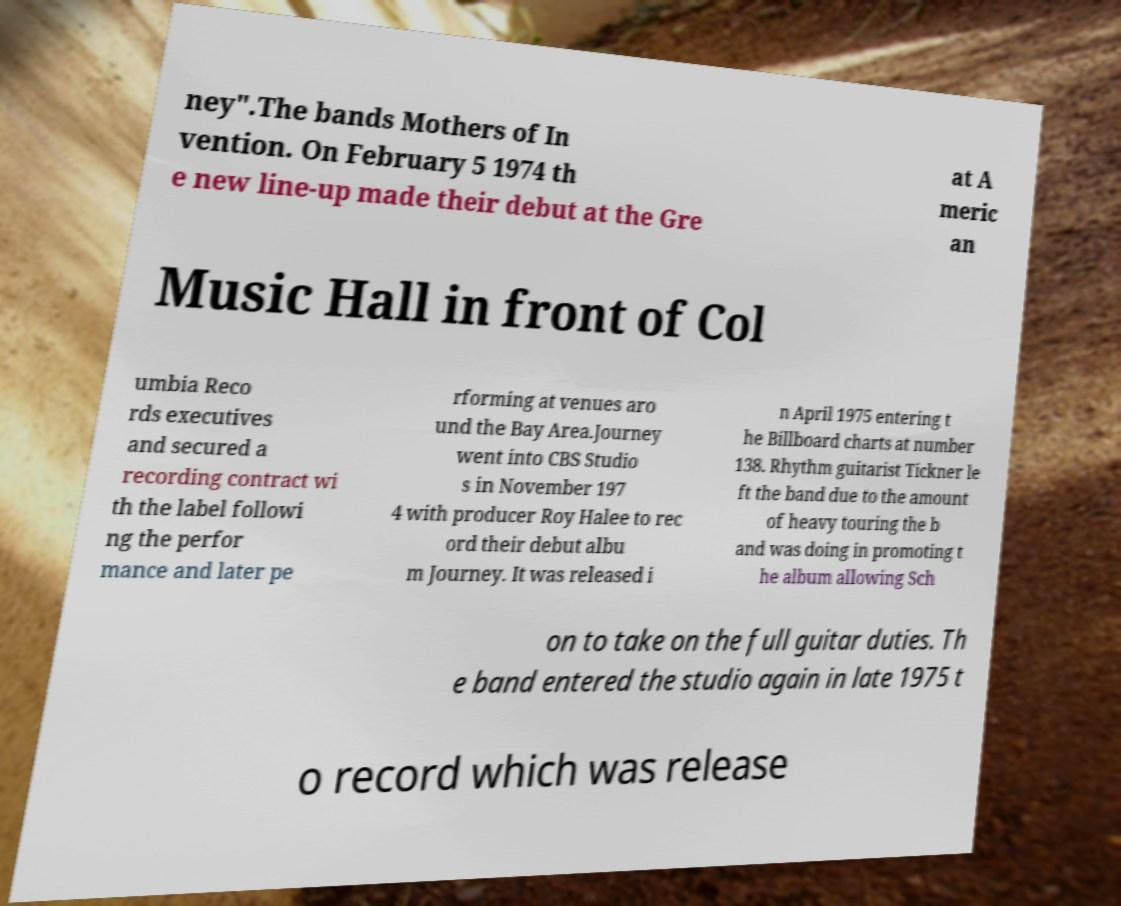Can you read and provide the text displayed in the image?This photo seems to have some interesting text. Can you extract and type it out for me? ney".The bands Mothers of In vention. On February 5 1974 th e new line-up made their debut at the Gre at A meric an Music Hall in front of Col umbia Reco rds executives and secured a recording contract wi th the label followi ng the perfor mance and later pe rforming at venues aro und the Bay Area.Journey went into CBS Studio s in November 197 4 with producer Roy Halee to rec ord their debut albu m Journey. It was released i n April 1975 entering t he Billboard charts at number 138. Rhythm guitarist Tickner le ft the band due to the amount of heavy touring the b and was doing in promoting t he album allowing Sch on to take on the full guitar duties. Th e band entered the studio again in late 1975 t o record which was release 